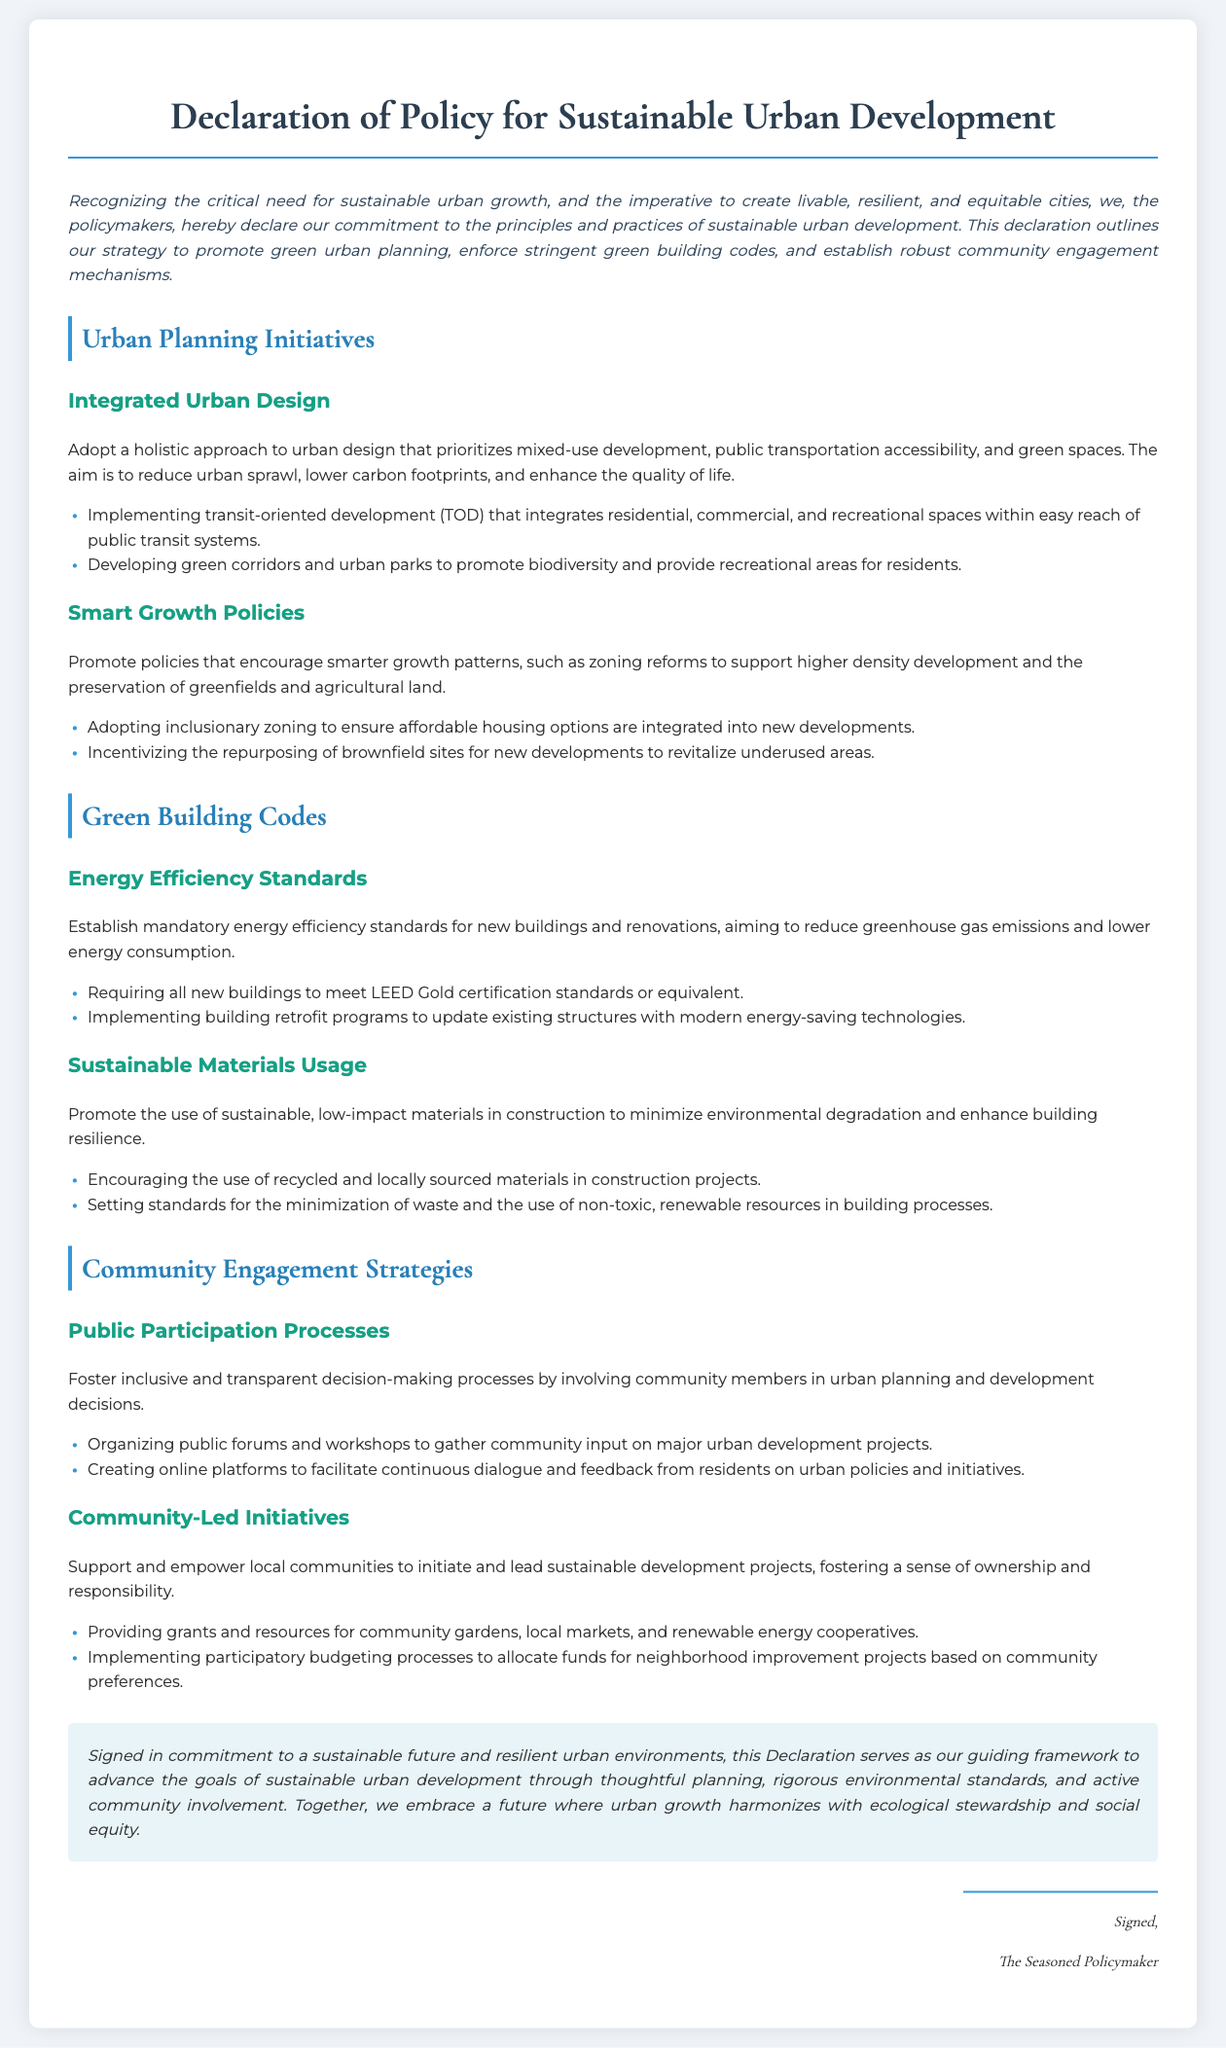What is the title of the document? The title of the document is prominently displayed at the beginning of the rendered content.
Answer: Declaration of Policy for Sustainable Urban Development What is the main aim of the Urban Planning Initiatives section? The section outlines strategies to improve urban design and development to create sustainable cities.
Answer: Promote green urban planning What certification must new buildings meet according to the Green Building Codes? The document specifies energy standards for new buildings within the building code section.
Answer: LEED Gold certification What is one community engagement strategy mentioned in the document? The section outlines specific methods to involve the community in decision-making processes.
Answer: Organizing public forums How many sections are there in the document? The document is divided into several key sections which are clearly labeled.
Answer: Three What are the two focused areas within the Green Building Codes? The document highlights specific emphasis areas that fall under the green building framework.
Answer: Energy Efficiency Standards and Sustainable Materials Usage What kind of zoning is encouraged to ensure affordable housing options? This refers to the specific zoning practice mentioned in the Smart Growth Policies section.
Answer: Inclusionary zoning What phrase begins the closing statement of the document? The closing paragraph summarizes the declaration and its commitment to sustainable urban development.
Answer: Signed in commitment to a sustainable future 